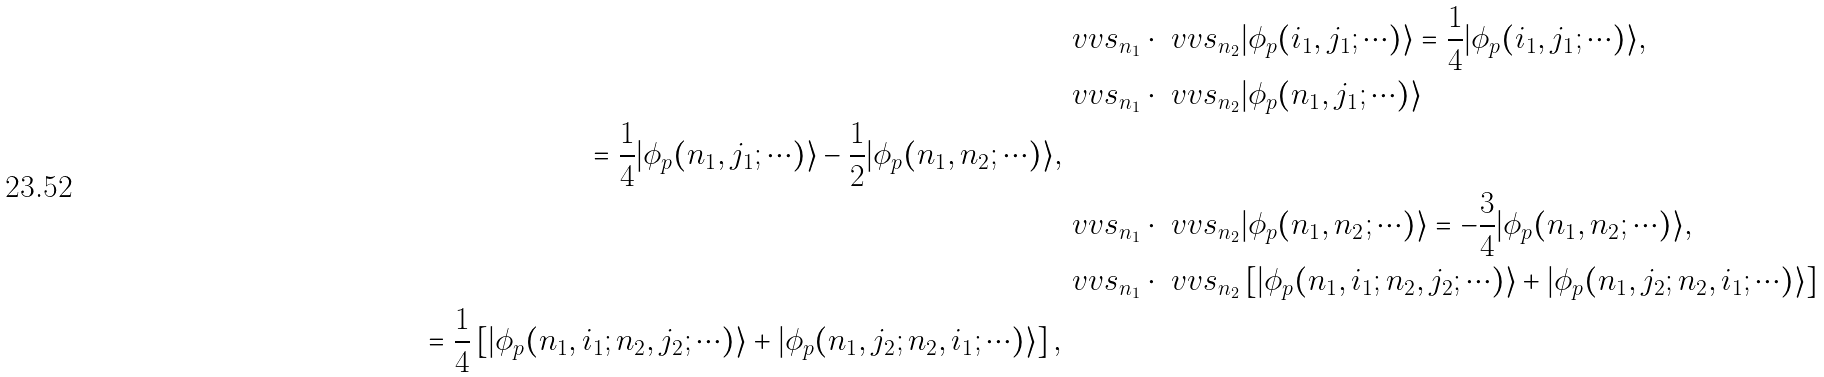Convert formula to latex. <formula><loc_0><loc_0><loc_500><loc_500>& \ v v { s } _ { n _ { 1 } } \cdot \ v v { s } _ { n _ { 2 } } | \phi _ { p } ( i _ { 1 } , j _ { 1 } ; \cdots ) \rangle = \frac { 1 } { 4 } | \phi _ { p } ( i _ { 1 } , j _ { 1 } ; \cdots ) \rangle , \\ & \ v v { s } _ { n _ { 1 } } \cdot \ v v { s } _ { n _ { 2 } } | \phi _ { p } ( n _ { 1 } , j _ { 1 } ; \cdots ) \rangle \\ \quad = \frac { 1 } { 4 } | \phi _ { p } ( n _ { 1 } , j _ { 1 } ; \cdots ) \rangle - \frac { 1 } { 2 } | \phi _ { p } ( n _ { 1 } , n _ { 2 } ; \cdots ) \rangle , \\ & \ v v { s } _ { n _ { 1 } } \cdot \ v v { s } _ { n _ { 2 } } | \phi _ { p } ( n _ { 1 } , n _ { 2 } ; \cdots ) \rangle = - \frac { 3 } { 4 } | \phi _ { p } ( n _ { 1 } , n _ { 2 } ; \cdots ) \rangle , \\ & \ v v { s } _ { n _ { 1 } } \cdot \ v v { s } _ { n _ { 2 } } \left [ | \phi _ { p } ( n _ { 1 } , i _ { 1 } ; n _ { 2 } , j _ { 2 } ; \cdots ) \rangle + | \phi _ { p } ( n _ { 1 } , j _ { 2 } ; n _ { 2 } , i _ { 1 } ; \cdots ) \rangle \right ] \\ \quad = \frac { 1 } { 4 } \left [ | \phi _ { p } ( n _ { 1 } , i _ { 1 } ; n _ { 2 } , j _ { 2 } ; \cdots ) \rangle + | \phi _ { p } ( n _ { 1 } , j _ { 2 } ; n _ { 2 } , i _ { 1 } ; \cdots ) \rangle \right ] ,</formula> 